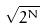Convert formula to latex. <formula><loc_0><loc_0><loc_500><loc_500>\sqrt { 2 ^ { N } }</formula> 